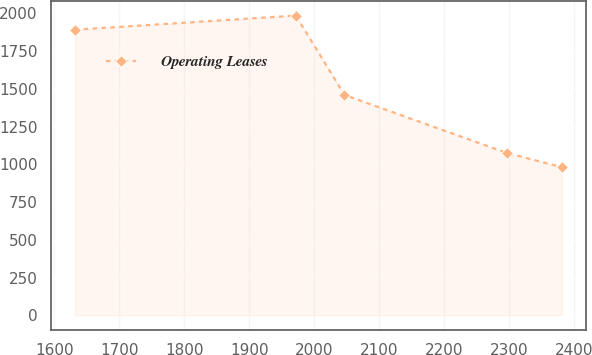<chart> <loc_0><loc_0><loc_500><loc_500><line_chart><ecel><fcel>Operating Leases<nl><fcel>1631.59<fcel>1891.45<nl><fcel>1971.84<fcel>1985.4<nl><fcel>2046.86<fcel>1459.39<nl><fcel>2297.01<fcel>1074.72<nl><fcel>2381.81<fcel>980.77<nl></chart> 